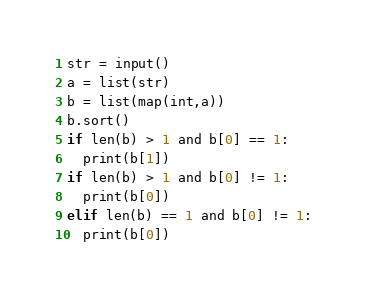Convert code to text. <code><loc_0><loc_0><loc_500><loc_500><_Python_>str = input()
a = list(str)
b = list(map(int,a))
b.sort()
if len(b) > 1 and b[0] == 1:
  print(b[1])
if len(b) > 1 and b[0] != 1:
  print(b[0])
elif len(b) == 1 and b[0] != 1:
  print(b[0])</code> 